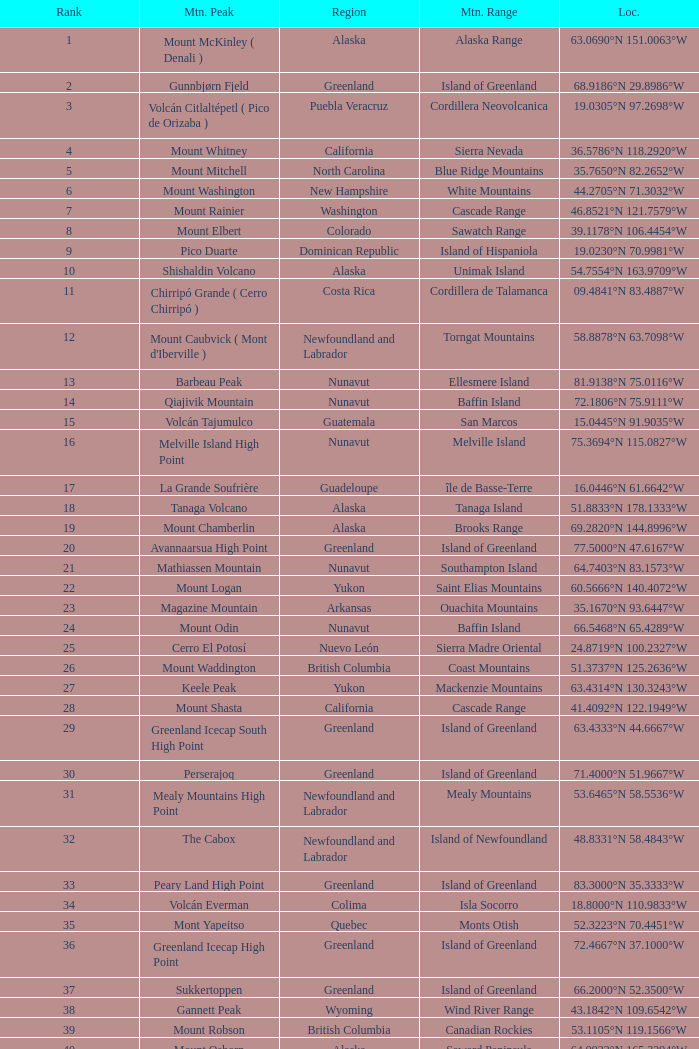Identify the mountain summit with a ranking of 62? Cerro Nube ( Quie Yelaag ). 